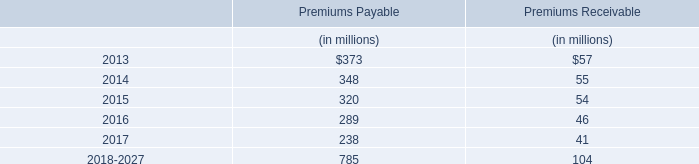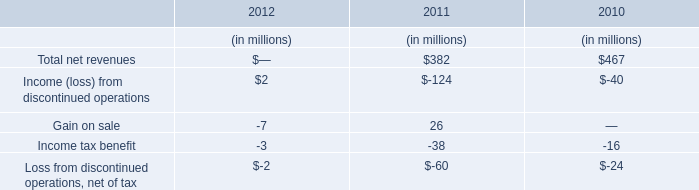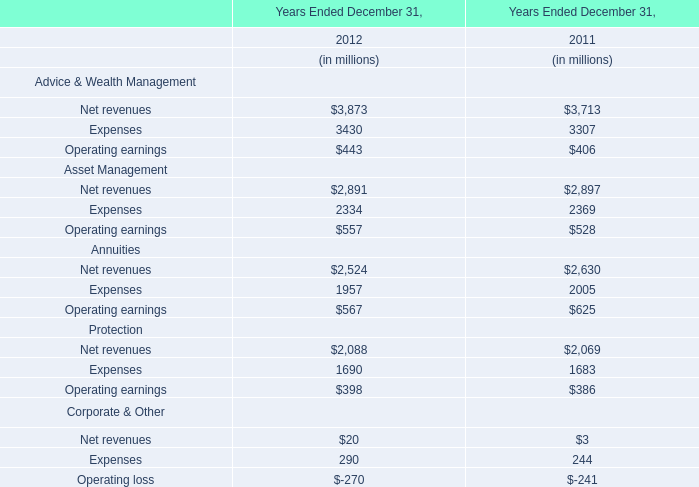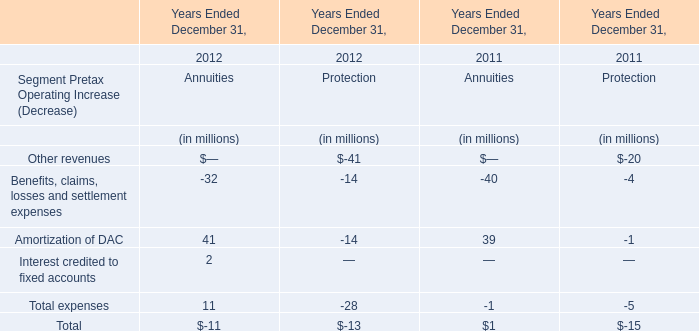If Amortization of DAC of Annuities' Segment Pretax Operating develops with the same growth rate in 2012, what will it reach in 2013? (in million) 
Computations: (41 + ((41 * (41 - 39)) / 39))
Answer: 43.10256. 